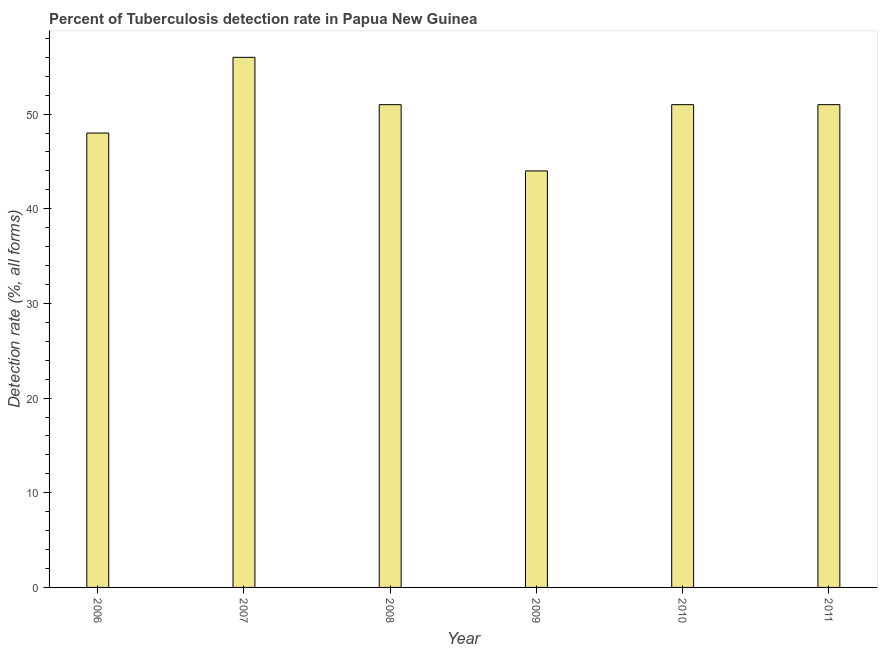What is the title of the graph?
Provide a succinct answer. Percent of Tuberculosis detection rate in Papua New Guinea. What is the label or title of the X-axis?
Your answer should be compact. Year. What is the label or title of the Y-axis?
Provide a short and direct response. Detection rate (%, all forms). What is the detection rate of tuberculosis in 2009?
Provide a succinct answer. 44. Across all years, what is the maximum detection rate of tuberculosis?
Your answer should be very brief. 56. Across all years, what is the minimum detection rate of tuberculosis?
Your response must be concise. 44. What is the sum of the detection rate of tuberculosis?
Your response must be concise. 301. What is the difference between the detection rate of tuberculosis in 2006 and 2011?
Provide a succinct answer. -3. What is the average detection rate of tuberculosis per year?
Ensure brevity in your answer.  50. What is the ratio of the detection rate of tuberculosis in 2007 to that in 2011?
Make the answer very short. 1.1. Is the detection rate of tuberculosis in 2007 less than that in 2009?
Provide a short and direct response. No. What is the difference between the highest and the second highest detection rate of tuberculosis?
Your response must be concise. 5. In how many years, is the detection rate of tuberculosis greater than the average detection rate of tuberculosis taken over all years?
Provide a short and direct response. 4. How many bars are there?
Your answer should be compact. 6. Are all the bars in the graph horizontal?
Your answer should be compact. No. Are the values on the major ticks of Y-axis written in scientific E-notation?
Your answer should be very brief. No. What is the Detection rate (%, all forms) of 2006?
Ensure brevity in your answer.  48. What is the Detection rate (%, all forms) in 2007?
Ensure brevity in your answer.  56. What is the Detection rate (%, all forms) in 2010?
Provide a short and direct response. 51. What is the Detection rate (%, all forms) in 2011?
Provide a short and direct response. 51. What is the difference between the Detection rate (%, all forms) in 2006 and 2008?
Offer a very short reply. -3. What is the difference between the Detection rate (%, all forms) in 2006 and 2011?
Your answer should be very brief. -3. What is the difference between the Detection rate (%, all forms) in 2007 and 2008?
Offer a terse response. 5. What is the difference between the Detection rate (%, all forms) in 2007 and 2009?
Keep it short and to the point. 12. What is the difference between the Detection rate (%, all forms) in 2008 and 2011?
Ensure brevity in your answer.  0. What is the difference between the Detection rate (%, all forms) in 2010 and 2011?
Ensure brevity in your answer.  0. What is the ratio of the Detection rate (%, all forms) in 2006 to that in 2007?
Ensure brevity in your answer.  0.86. What is the ratio of the Detection rate (%, all forms) in 2006 to that in 2008?
Keep it short and to the point. 0.94. What is the ratio of the Detection rate (%, all forms) in 2006 to that in 2009?
Ensure brevity in your answer.  1.09. What is the ratio of the Detection rate (%, all forms) in 2006 to that in 2010?
Give a very brief answer. 0.94. What is the ratio of the Detection rate (%, all forms) in 2006 to that in 2011?
Your response must be concise. 0.94. What is the ratio of the Detection rate (%, all forms) in 2007 to that in 2008?
Make the answer very short. 1.1. What is the ratio of the Detection rate (%, all forms) in 2007 to that in 2009?
Your answer should be very brief. 1.27. What is the ratio of the Detection rate (%, all forms) in 2007 to that in 2010?
Your answer should be compact. 1.1. What is the ratio of the Detection rate (%, all forms) in 2007 to that in 2011?
Offer a terse response. 1.1. What is the ratio of the Detection rate (%, all forms) in 2008 to that in 2009?
Your answer should be compact. 1.16. What is the ratio of the Detection rate (%, all forms) in 2008 to that in 2010?
Offer a very short reply. 1. What is the ratio of the Detection rate (%, all forms) in 2009 to that in 2010?
Keep it short and to the point. 0.86. What is the ratio of the Detection rate (%, all forms) in 2009 to that in 2011?
Your answer should be compact. 0.86. 